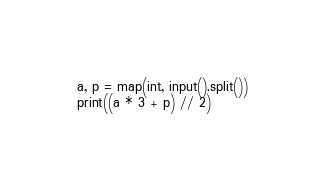Convert code to text. <code><loc_0><loc_0><loc_500><loc_500><_Python_>a, p = map(int, input().split())
print((a * 3 + p) // 2)
</code> 